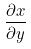Convert formula to latex. <formula><loc_0><loc_0><loc_500><loc_500>\frac { \partial x } { \partial y }</formula> 